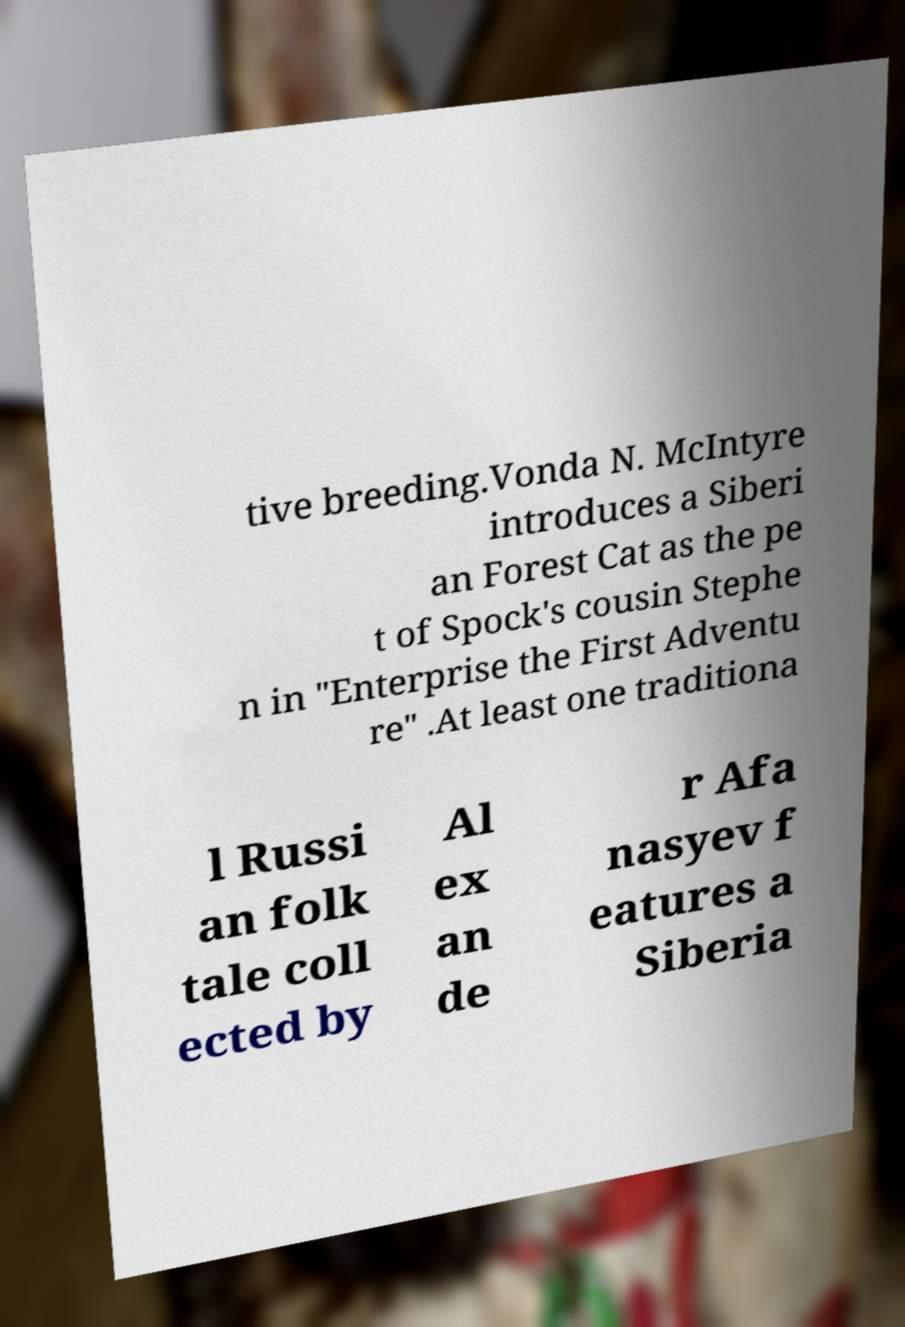What messages or text are displayed in this image? I need them in a readable, typed format. tive breeding.Vonda N. McIntyre introduces a Siberi an Forest Cat as the pe t of Spock's cousin Stephe n in "Enterprise the First Adventu re" .At least one traditiona l Russi an folk tale coll ected by Al ex an de r Afa nasyev f eatures a Siberia 